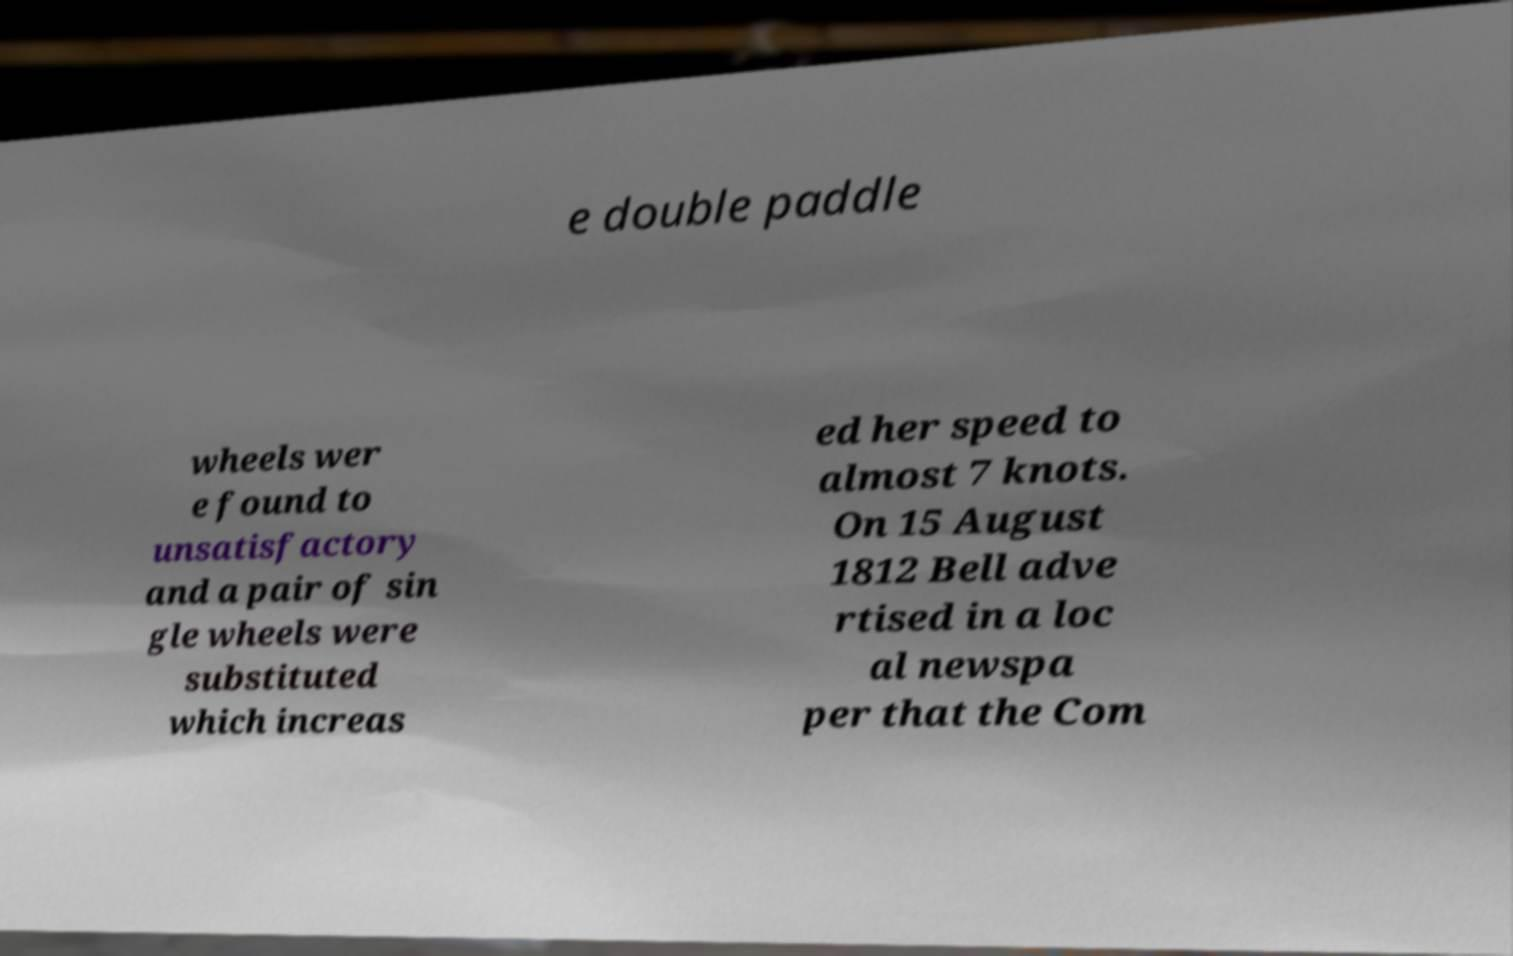Can you accurately transcribe the text from the provided image for me? e double paddle wheels wer e found to unsatisfactory and a pair of sin gle wheels were substituted which increas ed her speed to almost 7 knots. On 15 August 1812 Bell adve rtised in a loc al newspa per that the Com 